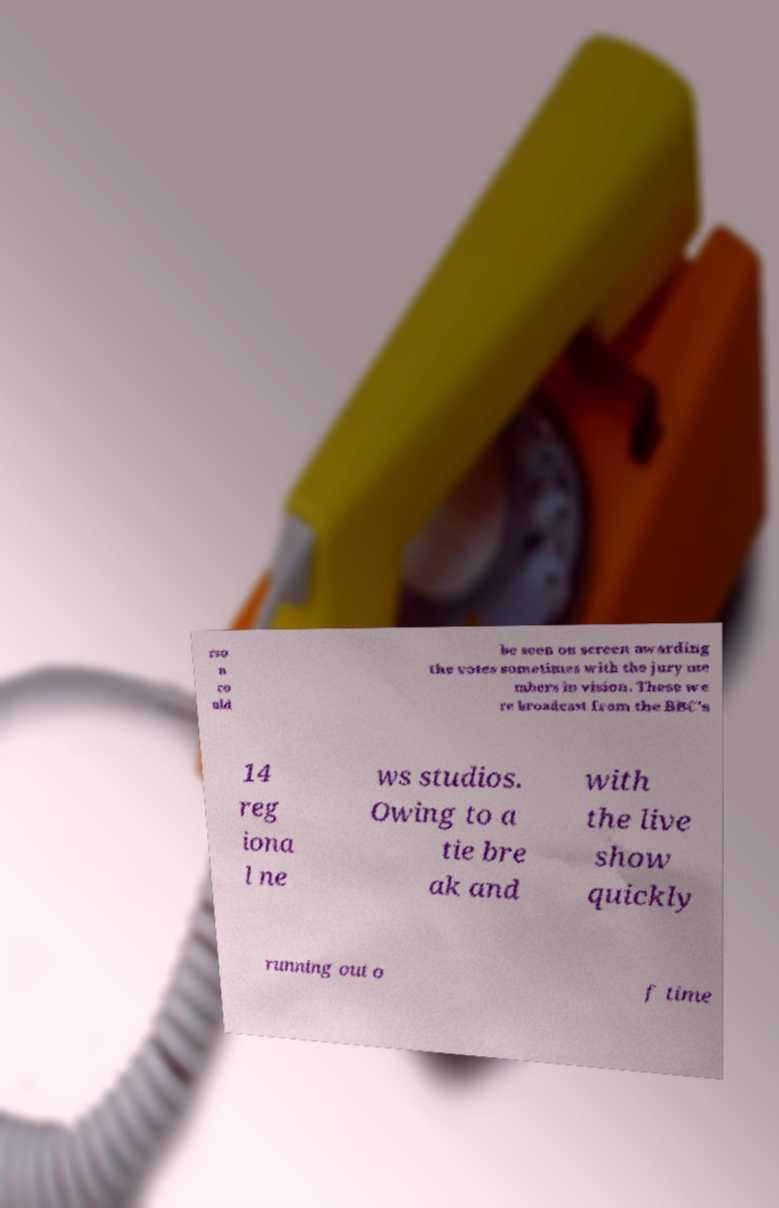Can you accurately transcribe the text from the provided image for me? rso n co uld be seen on screen awarding the votes sometimes with the jury me mbers in vision. These we re broadcast from the BBC's 14 reg iona l ne ws studios. Owing to a tie bre ak and with the live show quickly running out o f time 